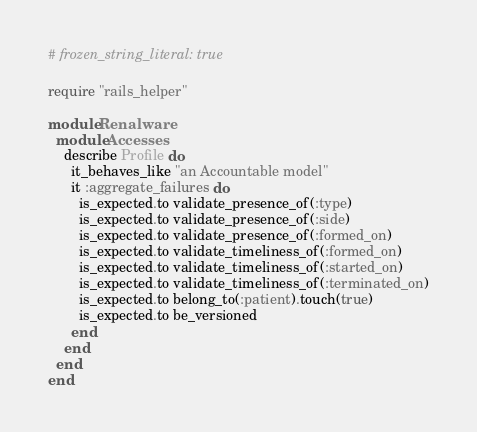Convert code to text. <code><loc_0><loc_0><loc_500><loc_500><_Ruby_># frozen_string_literal: true

require "rails_helper"

module Renalware
  module Accesses
    describe Profile do
      it_behaves_like "an Accountable model"
      it :aggregate_failures do
        is_expected.to validate_presence_of(:type)
        is_expected.to validate_presence_of(:side)
        is_expected.to validate_presence_of(:formed_on)
        is_expected.to validate_timeliness_of(:formed_on)
        is_expected.to validate_timeliness_of(:started_on)
        is_expected.to validate_timeliness_of(:terminated_on)
        is_expected.to belong_to(:patient).touch(true)
        is_expected.to be_versioned
      end
    end
  end
end
</code> 